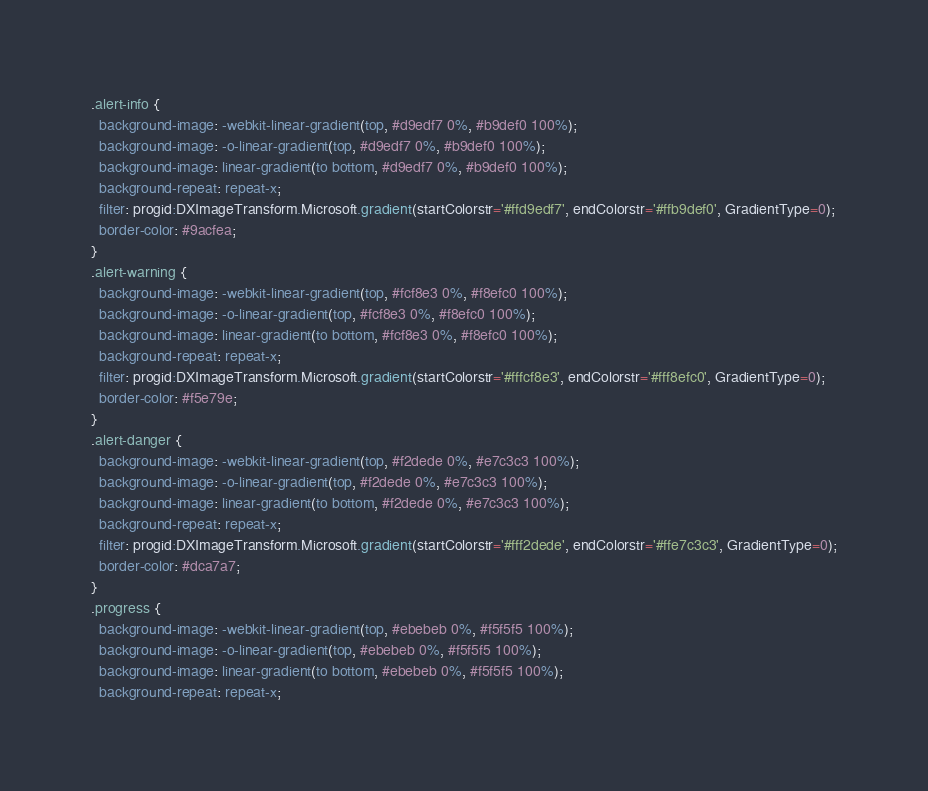Convert code to text. <code><loc_0><loc_0><loc_500><loc_500><_CSS_>.alert-info {
  background-image: -webkit-linear-gradient(top, #d9edf7 0%, #b9def0 100%);
  background-image: -o-linear-gradient(top, #d9edf7 0%, #b9def0 100%);
  background-image: linear-gradient(to bottom, #d9edf7 0%, #b9def0 100%);
  background-repeat: repeat-x;
  filter: progid:DXImageTransform.Microsoft.gradient(startColorstr='#ffd9edf7', endColorstr='#ffb9def0', GradientType=0);
  border-color: #9acfea;
}
.alert-warning {
  background-image: -webkit-linear-gradient(top, #fcf8e3 0%, #f8efc0 100%);
  background-image: -o-linear-gradient(top, #fcf8e3 0%, #f8efc0 100%);
  background-image: linear-gradient(to bottom, #fcf8e3 0%, #f8efc0 100%);
  background-repeat: repeat-x;
  filter: progid:DXImageTransform.Microsoft.gradient(startColorstr='#fffcf8e3', endColorstr='#fff8efc0', GradientType=0);
  border-color: #f5e79e;
}
.alert-danger {
  background-image: -webkit-linear-gradient(top, #f2dede 0%, #e7c3c3 100%);
  background-image: -o-linear-gradient(top, #f2dede 0%, #e7c3c3 100%);
  background-image: linear-gradient(to bottom, #f2dede 0%, #e7c3c3 100%);
  background-repeat: repeat-x;
  filter: progid:DXImageTransform.Microsoft.gradient(startColorstr='#fff2dede', endColorstr='#ffe7c3c3', GradientType=0);
  border-color: #dca7a7;
}
.progress {
  background-image: -webkit-linear-gradient(top, #ebebeb 0%, #f5f5f5 100%);
  background-image: -o-linear-gradient(top, #ebebeb 0%, #f5f5f5 100%);
  background-image: linear-gradient(to bottom, #ebebeb 0%, #f5f5f5 100%);
  background-repeat: repeat-x;</code> 